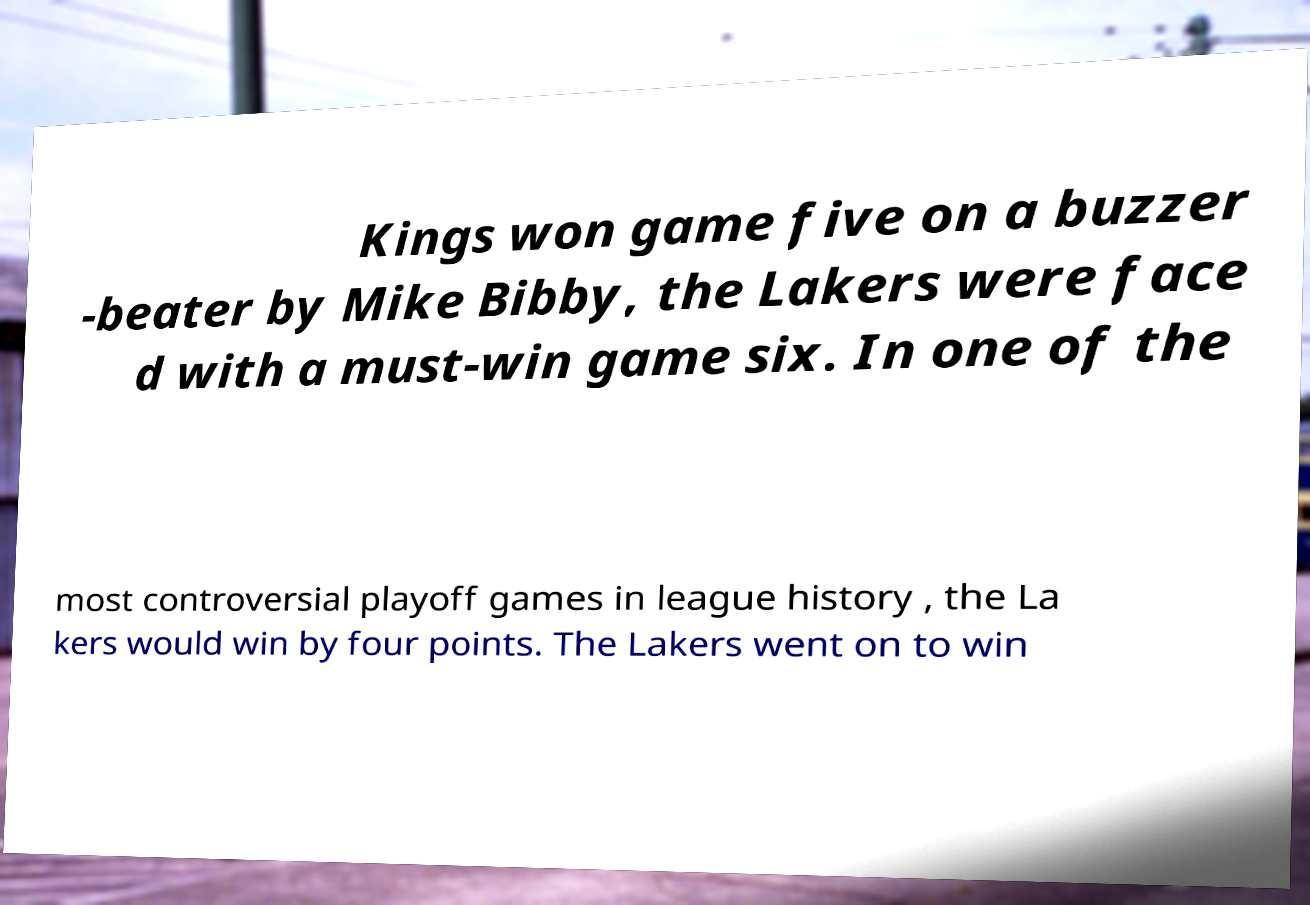Please identify and transcribe the text found in this image. Kings won game five on a buzzer -beater by Mike Bibby, the Lakers were face d with a must-win game six. In one of the most controversial playoff games in league history , the La kers would win by four points. The Lakers went on to win 